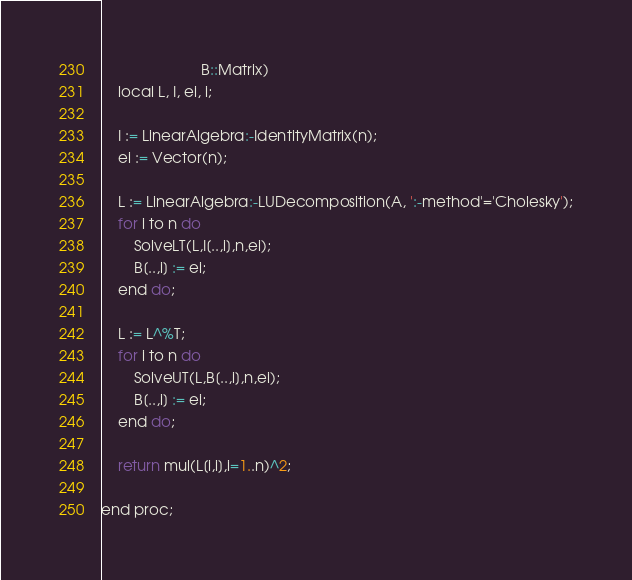Convert code to text. <code><loc_0><loc_0><loc_500><loc_500><_ObjectiveC_>                        B::Matrix)
    local L, I, ei, i;
    
    I := LinearAlgebra:-IdentityMatrix(n);
    ei := Vector(n);

    L := LinearAlgebra:-LUDecomposition(A, ':-method'='Cholesky');
    for i to n do
        SolveLT(L,I[..,i],n,ei);
        B[..,i] := ei;
    end do;

    L := L^%T;
    for i to n do
        SolveUT(L,B[..,i],n,ei);
        B[..,i] := ei;
    end do;
    
    return mul(L[i,i],i=1..n)^2;

end proc;</code> 